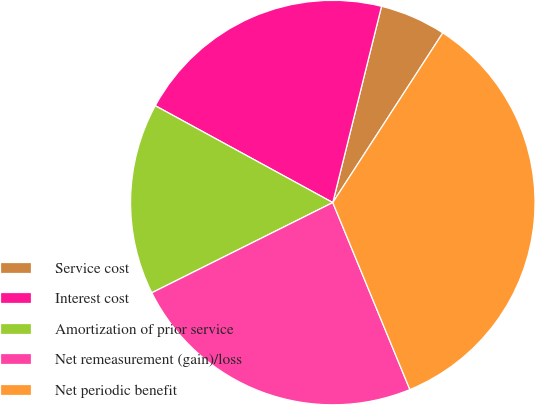Convert chart to OTSL. <chart><loc_0><loc_0><loc_500><loc_500><pie_chart><fcel>Service cost<fcel>Interest cost<fcel>Amortization of prior service<fcel>Net remeasurement (gain)/loss<fcel>Net periodic benefit<nl><fcel>5.28%<fcel>20.92%<fcel>15.31%<fcel>23.86%<fcel>34.62%<nl></chart> 